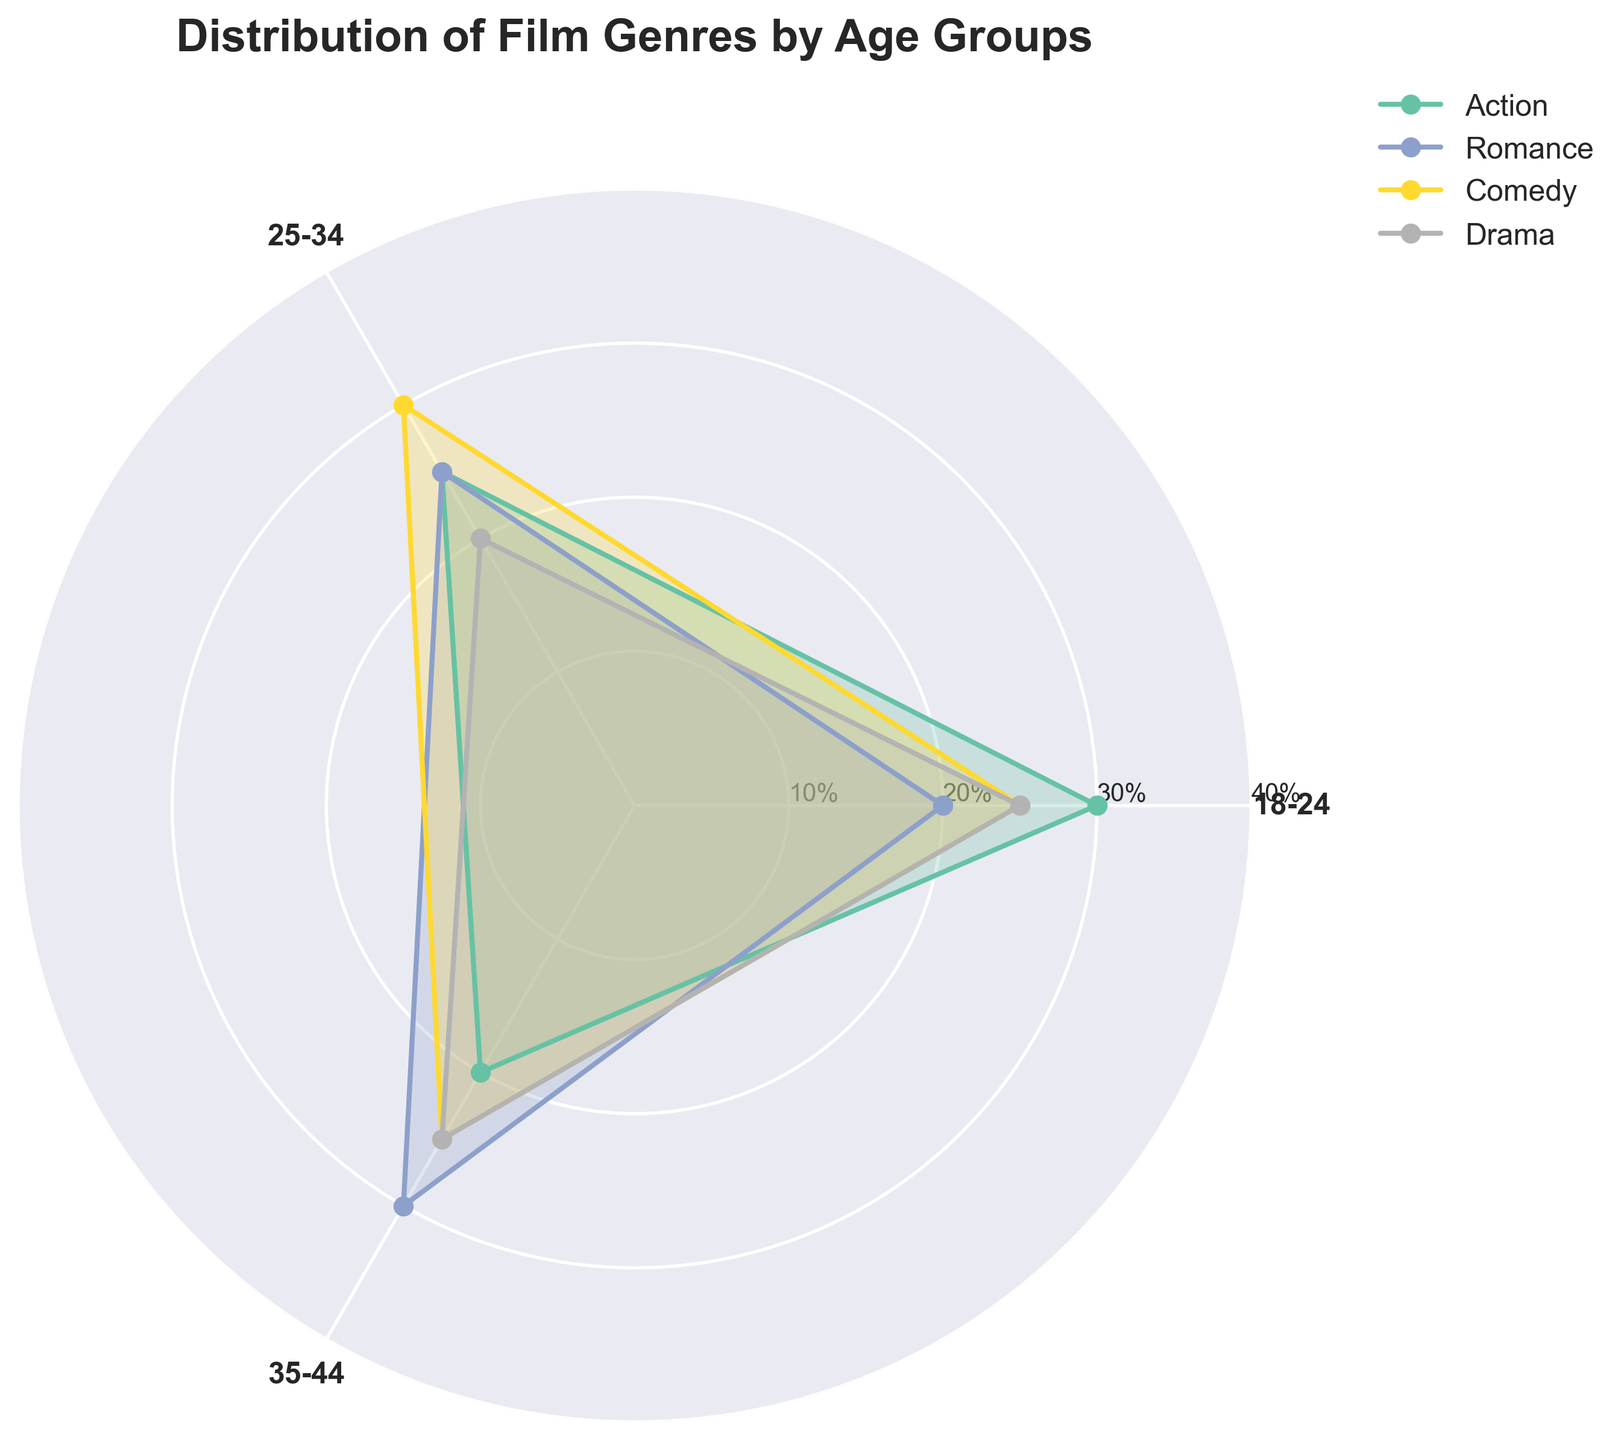What is the title of the figure? The title of the figure is prominently placed at the top. It states, "Distribution of Film Genres by Age Groups."
Answer: Distribution of Film Genres by Age Groups Which age group is represented on the left side of the chart? The age groups are represented around the circular axis. The left side corresponds to "18-24" based on the original data order.
Answer: 18-24 Which genre has the highest percentage among the 25-34 age group? By looking at the segments for the 25-34 age group, the genre with the longest edge in this segment is "Comedy."
Answer: Comedy How does the preference for Romance change from the 18-24 age group to the 35-44 age group? The percentage for Romance increases from 20% in the 18-24 age group to 30% in the 35-44 age group.
Answer: Increases Compare the Drama genre between the 18-24 and 35-44 age groups. Which age group prefers it more? Evaluating the length of the edge for Drama, both age groups have the same value of 25%.
Answer: Both are equal Among the first three age groups, which genre shows the most variation in preferences? To determine this, we compare the values across all age groups. Romance ranges from 20% to 30%, a variation of 10 percentage points. Other genres vary less.
Answer: Romance What is the average percentage for Action across the 18-24, 25-34, and 35-44 age groups? Adding the percentages for Action (30%, 25%, and 20%) and dividing by 3: (30 + 25 + 20) / 3 = 75 / 3
Answer: 25% Which genre sees a decrease in preference as age increases from 18-24 to 35-44? Action decreases from 30% in the 18-24 group to 25% in 25-34, and then to 20% in 35-44.
Answer: Action How does Comedy preference vary between the 25-34 and 45-54 age groups? Disregarding the actual plot but referring to data, for the 25-34 age group, Comedy is at 30%, while for the 45-54 age group, Comedy is at 20%, showing a decrease.
Answer: Decreases by 10% 